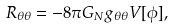Convert formula to latex. <formula><loc_0><loc_0><loc_500><loc_500>R _ { \theta \theta } = - 8 \pi G _ { N } g _ { \theta \theta } V [ \phi ] ,</formula> 